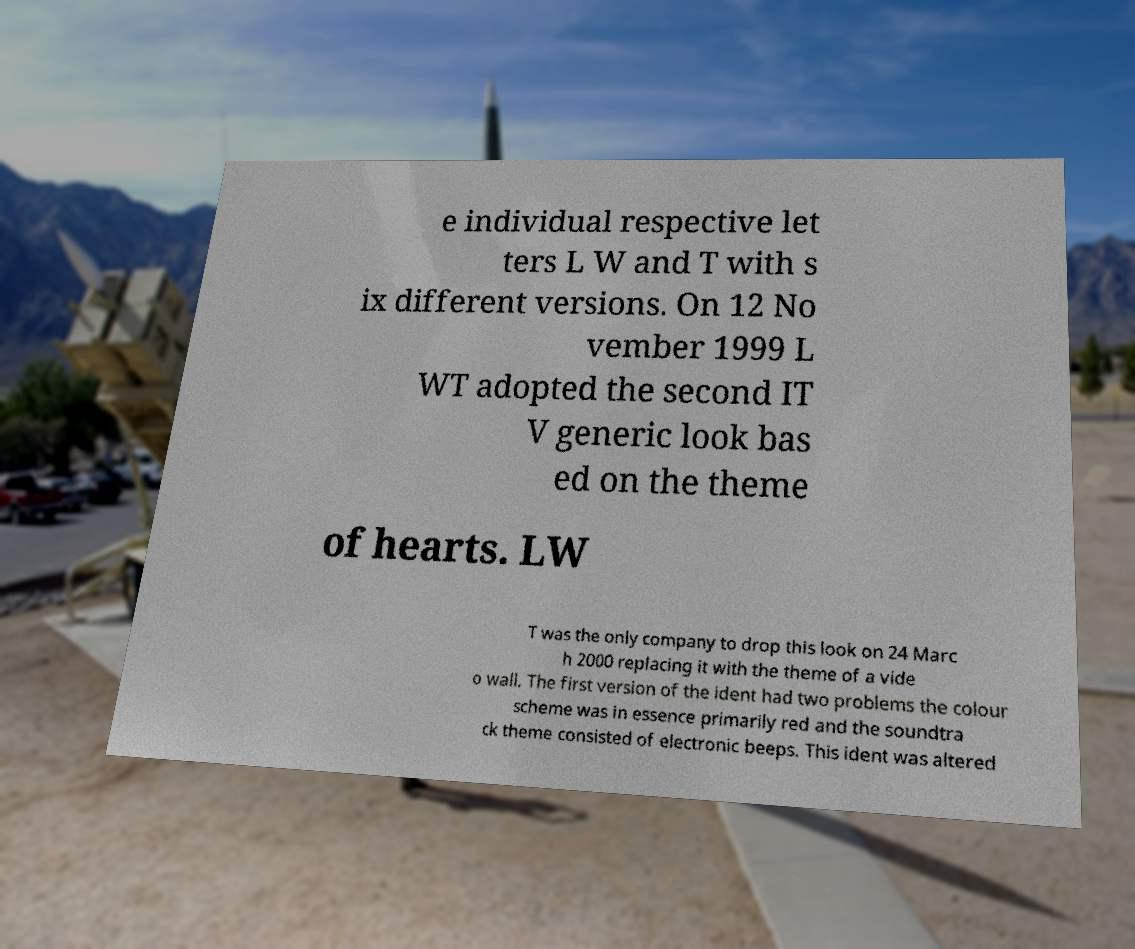Can you read and provide the text displayed in the image?This photo seems to have some interesting text. Can you extract and type it out for me? e individual respective let ters L W and T with s ix different versions. On 12 No vember 1999 L WT adopted the second IT V generic look bas ed on the theme of hearts. LW T was the only company to drop this look on 24 Marc h 2000 replacing it with the theme of a vide o wall. The first version of the ident had two problems the colour scheme was in essence primarily red and the soundtra ck theme consisted of electronic beeps. This ident was altered 